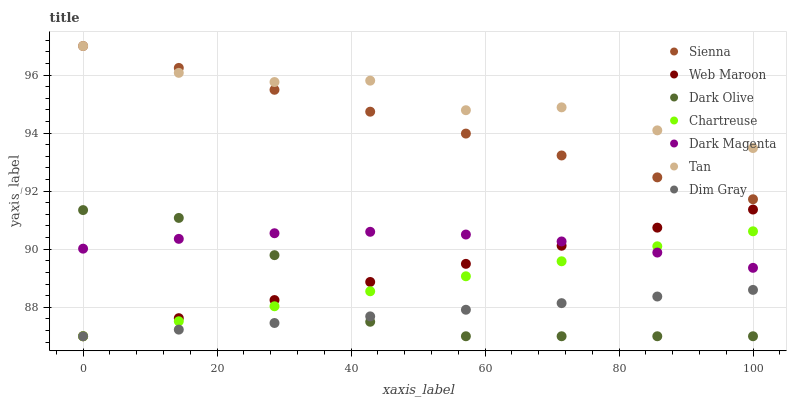Does Dim Gray have the minimum area under the curve?
Answer yes or no. Yes. Does Tan have the maximum area under the curve?
Answer yes or no. Yes. Does Dark Magenta have the minimum area under the curve?
Answer yes or no. No. Does Dark Magenta have the maximum area under the curve?
Answer yes or no. No. Is Dim Gray the smoothest?
Answer yes or no. Yes. Is Dark Olive the roughest?
Answer yes or no. Yes. Is Dark Magenta the smoothest?
Answer yes or no. No. Is Dark Magenta the roughest?
Answer yes or no. No. Does Dim Gray have the lowest value?
Answer yes or no. Yes. Does Dark Magenta have the lowest value?
Answer yes or no. No. Does Tan have the highest value?
Answer yes or no. Yes. Does Dark Magenta have the highest value?
Answer yes or no. No. Is Dark Magenta less than Tan?
Answer yes or no. Yes. Is Tan greater than Web Maroon?
Answer yes or no. Yes. Does Web Maroon intersect Chartreuse?
Answer yes or no. Yes. Is Web Maroon less than Chartreuse?
Answer yes or no. No. Is Web Maroon greater than Chartreuse?
Answer yes or no. No. Does Dark Magenta intersect Tan?
Answer yes or no. No. 